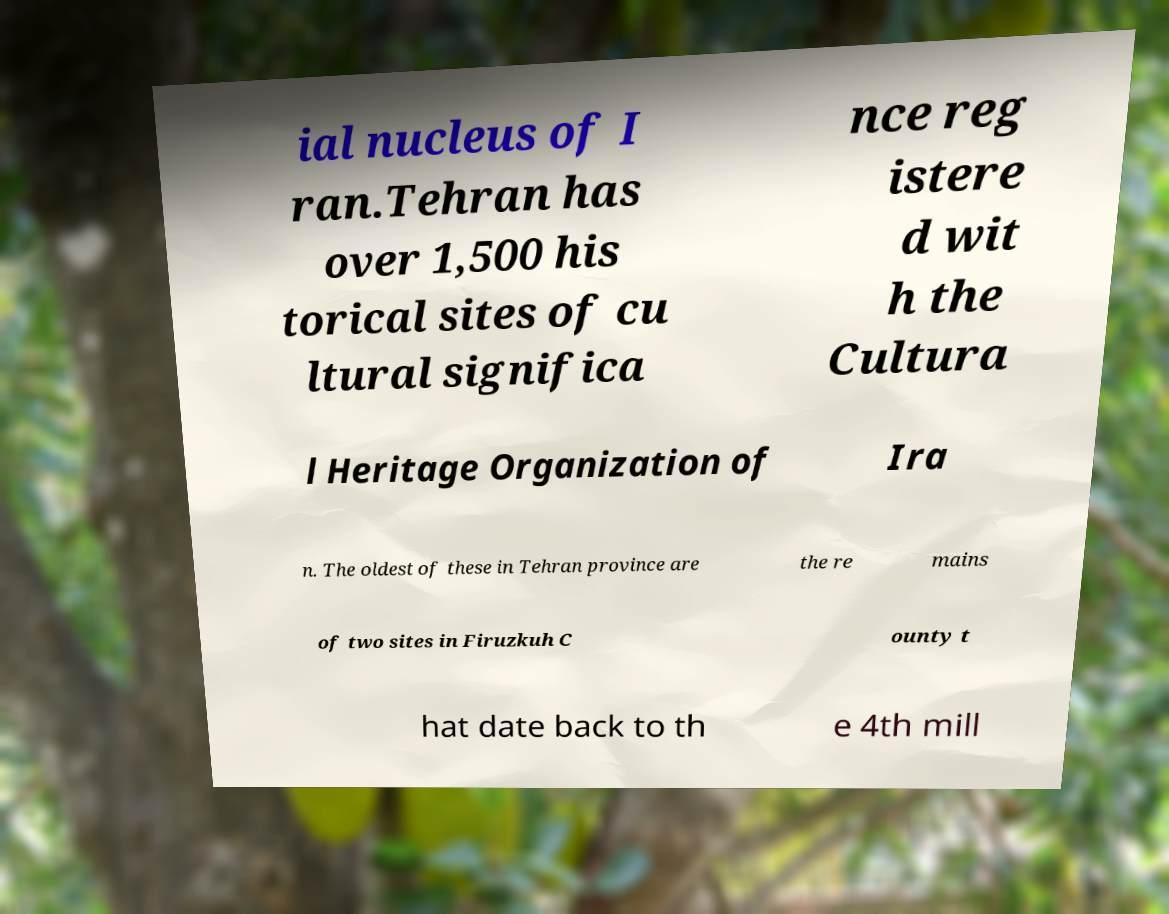Can you accurately transcribe the text from the provided image for me? ial nucleus of I ran.Tehran has over 1,500 his torical sites of cu ltural significa nce reg istere d wit h the Cultura l Heritage Organization of Ira n. The oldest of these in Tehran province are the re mains of two sites in Firuzkuh C ounty t hat date back to th e 4th mill 